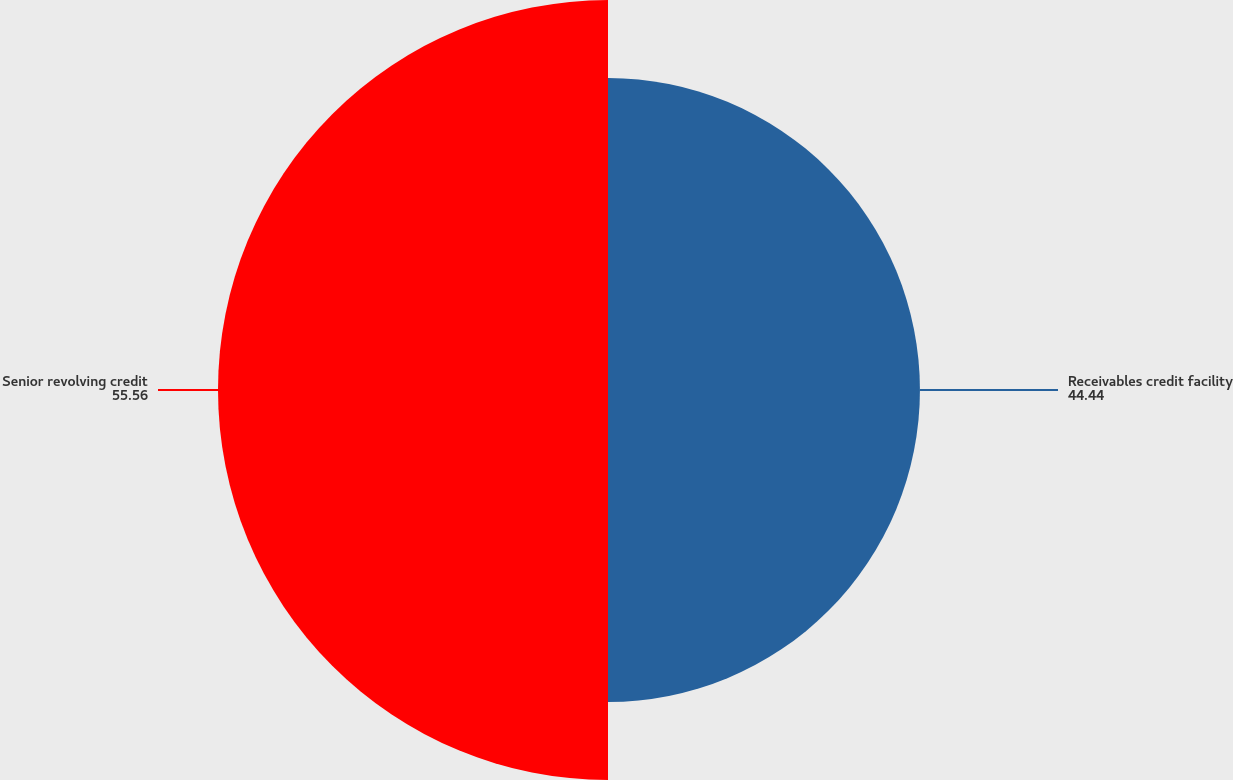<chart> <loc_0><loc_0><loc_500><loc_500><pie_chart><fcel>Receivables credit facility<fcel>Senior revolving credit<nl><fcel>44.44%<fcel>55.56%<nl></chart> 